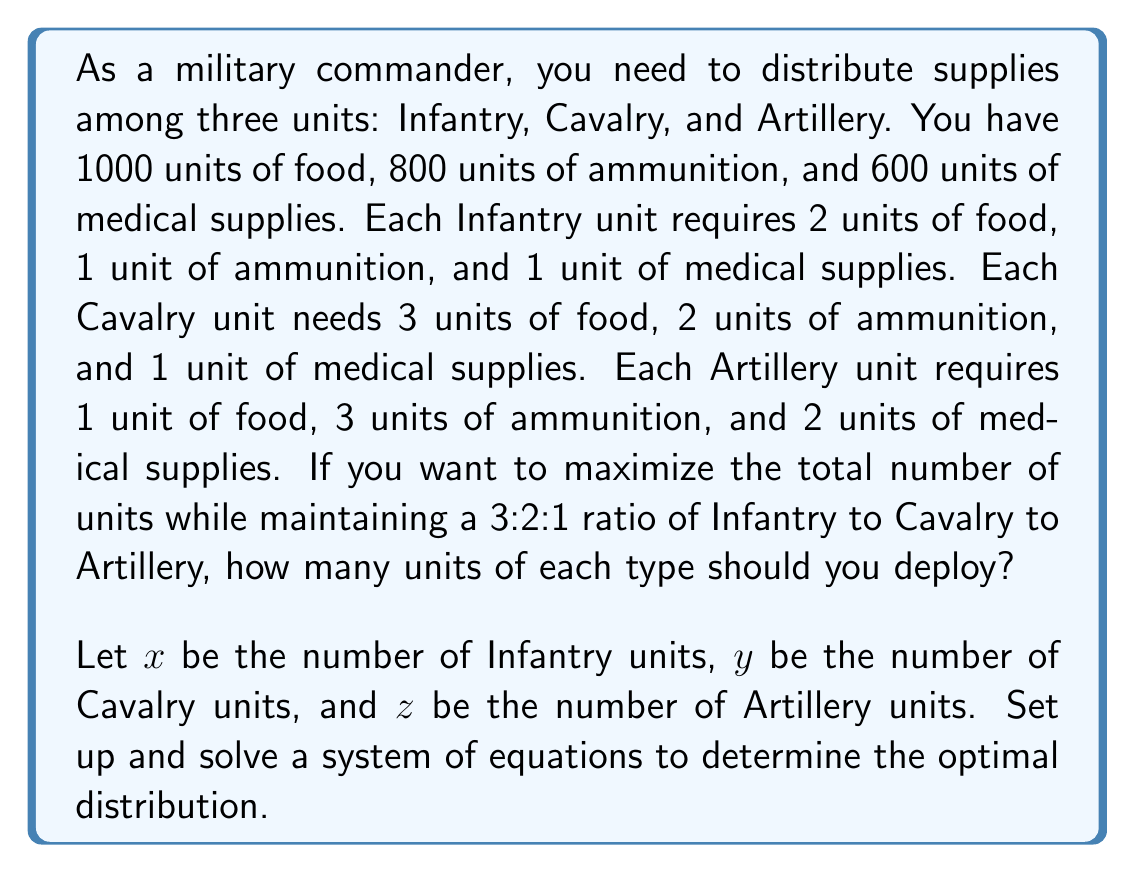Show me your answer to this math problem. To solve this problem, we need to set up a system of equations based on the given information:

1. Ratio equation:
   $\frac{x}{3} = \frac{y}{2} = \frac{z}{1}$
   This can be rewritten as: $x = 3y/2$ and $z = y/2$

2. Supply constraints:
   Food: $2x + 3y + z \leq 1000$
   Ammunition: $x + 2y + 3z \leq 800$
   Medical: $x + y + 2z \leq 600$

Substituting the ratio equations into the supply constraints:

Food: $2(3y/2) + 3y + (y/2) \leq 1000$
      $3y + 3y + y/2 \leq 1000$
      $13y/2 \leq 1000$
      $y \leq 153.85$

Ammunition: $(3y/2) + 2y + 3(y/2) \leq 800$
            $3y/2 + 2y + 3y/2 \leq 800$
            $5y \leq 800$
            $y \leq 160$

Medical: $(3y/2) + y + 2(y/2) \leq 600$
         $3y/2 + y + y \leq 600$
         $7y/2 \leq 600$
         $y \leq 171.43$

The most restrictive constraint is $y \leq 153.85$. To maintain integer values, we round down to $y = 153$.

Now we can calculate $x$ and $z$:
$x = 3y/2 = 3(153)/2 = 229.5$, which rounds down to 229
$z = y/2 = 153/2 = 76.5$, which rounds down to 76

To verify:
Food: $2(229) + 3(153) + 76 = 997 \leq 1000$
Ammunition: $229 + 2(153) + 3(76) = 763 \leq 800$
Medical: $229 + 153 + 2(76) = 534 \leq 600$

All constraints are satisfied.
Answer: Infantry units: 229
Cavalry units: 153
Artillery units: 76 